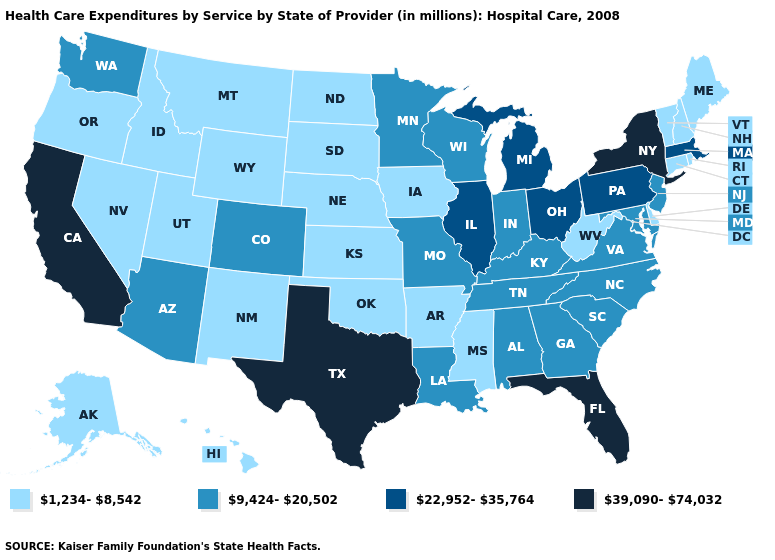What is the lowest value in the USA?
Write a very short answer. 1,234-8,542. Among the states that border West Virginia , which have the highest value?
Give a very brief answer. Ohio, Pennsylvania. Does Nevada have the highest value in the West?
Be succinct. No. Does the map have missing data?
Answer briefly. No. Does the map have missing data?
Short answer required. No. Which states have the lowest value in the Northeast?
Answer briefly. Connecticut, Maine, New Hampshire, Rhode Island, Vermont. Is the legend a continuous bar?
Short answer required. No. Name the states that have a value in the range 39,090-74,032?
Quick response, please. California, Florida, New York, Texas. What is the lowest value in the USA?
Answer briefly. 1,234-8,542. Does Kentucky have the lowest value in the South?
Quick response, please. No. Which states have the highest value in the USA?
Give a very brief answer. California, Florida, New York, Texas. Among the states that border West Virginia , which have the highest value?
Short answer required. Ohio, Pennsylvania. What is the lowest value in the Northeast?
Be succinct. 1,234-8,542. Is the legend a continuous bar?
Quick response, please. No. Name the states that have a value in the range 9,424-20,502?
Be succinct. Alabama, Arizona, Colorado, Georgia, Indiana, Kentucky, Louisiana, Maryland, Minnesota, Missouri, New Jersey, North Carolina, South Carolina, Tennessee, Virginia, Washington, Wisconsin. 